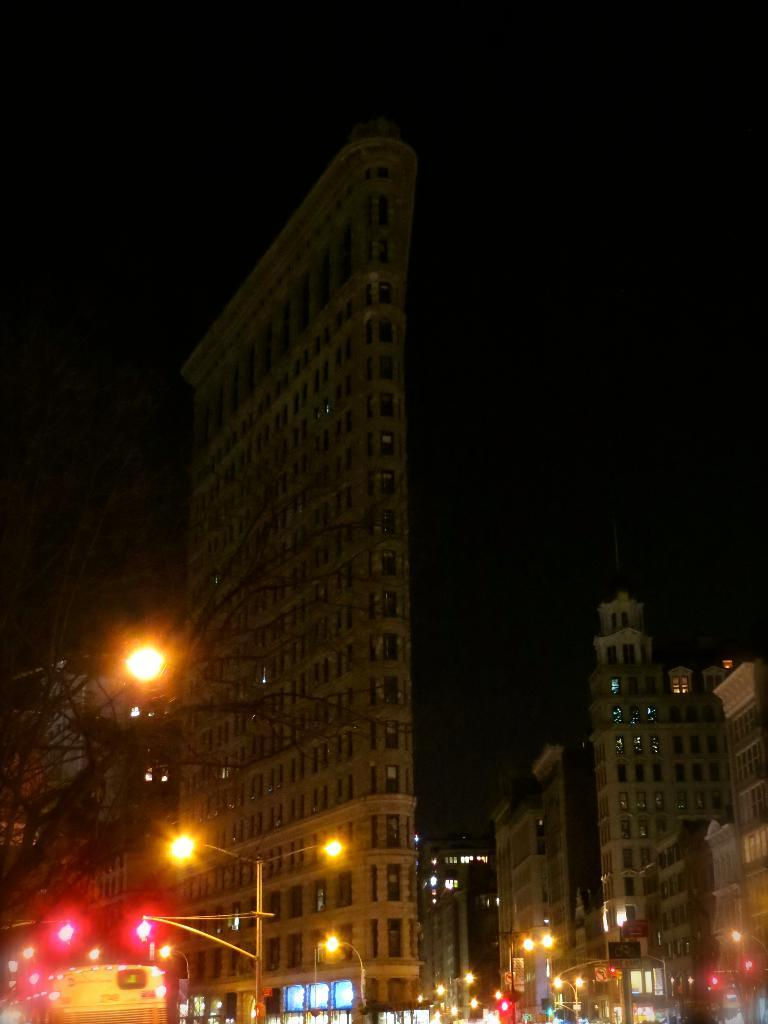What structures can be seen in the image? There are light poles in the image. What can be seen in the distance in the image? There are buildings in the background of the image. What is the color of the sky in the image? The sky appears to be black in color. What type of mask is being taught in the image? There is no mask or teaching activity present in the image. 